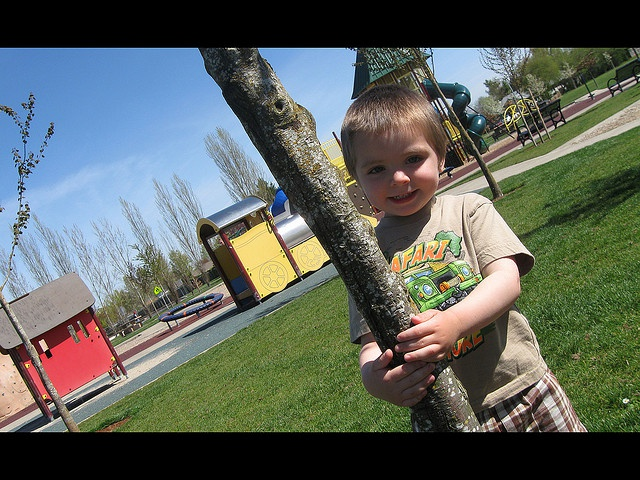Describe the objects in this image and their specific colors. I can see people in black, lightgray, maroon, and gray tones, bench in black, gray, darkgreen, and darkgray tones, and bench in black, gray, darkgreen, and darkgray tones in this image. 